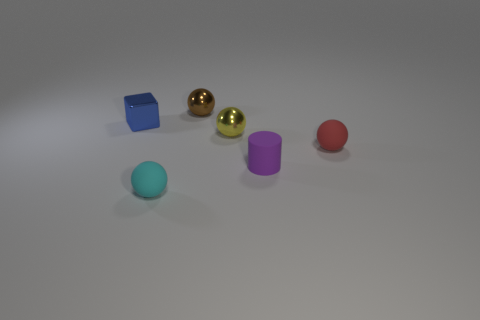Subtract 1 spheres. How many spheres are left? 3 Add 4 tiny blue metal balls. How many objects exist? 10 Subtract all cubes. How many objects are left? 5 Add 1 cyan objects. How many cyan objects exist? 2 Subtract 0 cyan cylinders. How many objects are left? 6 Subtract all purple matte things. Subtract all tiny gray things. How many objects are left? 5 Add 3 cyan matte objects. How many cyan matte objects are left? 4 